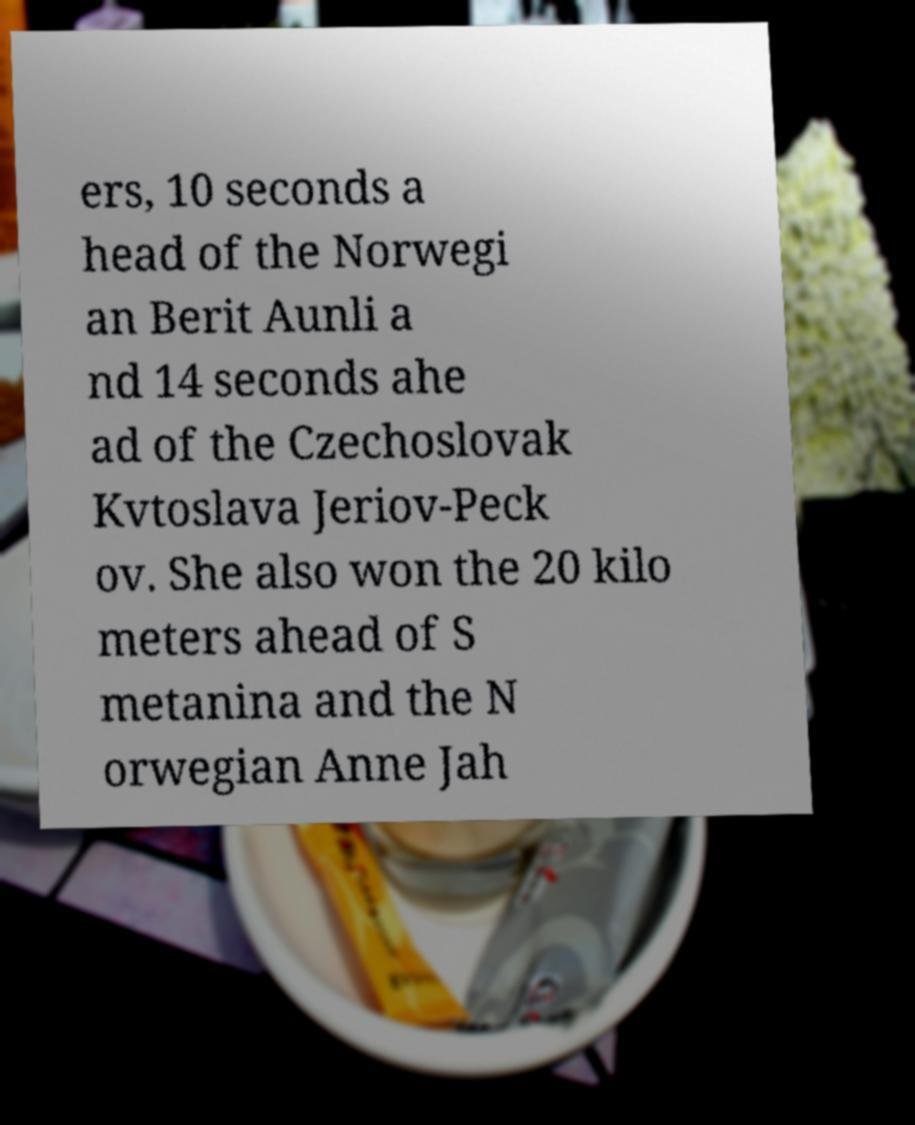Please read and relay the text visible in this image. What does it say? ers, 10 seconds a head of the Norwegi an Berit Aunli a nd 14 seconds ahe ad of the Czechoslovak Kvtoslava Jeriov-Peck ov. She also won the 20 kilo meters ahead of S metanina and the N orwegian Anne Jah 